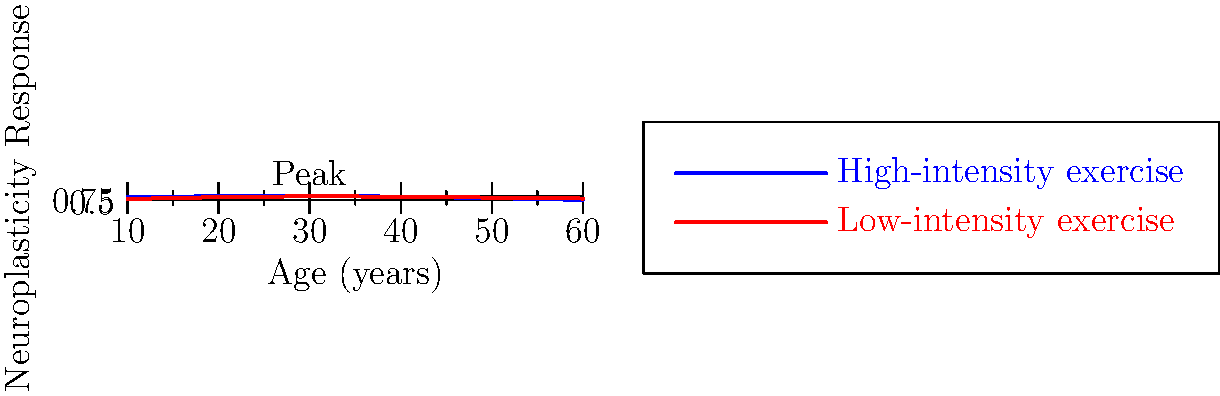Based on the graph showing neuroplasticity responses to exercise across different age groups, at which age does the difference in neuroplasticity response between high-intensity and low-intensity exercise appear to be the greatest? To determine the age at which the difference in neuroplasticity response between high-intensity and low-intensity exercise is greatest, we need to follow these steps:

1. Examine the two curves: blue for high-intensity exercise and red for low-intensity exercise.
2. Look for the point where the vertical distance between the two curves is largest.
3. Identify the age (x-axis value) corresponding to this point.

Analyzing the graph:
- At age 10, there's a small difference between the curves.
- The difference increases at age 20.
- At age 30, the curves are close together, with high-intensity slightly higher.
- At age 40, the curves almost overlap.
- At age 50, we see a notable separation between the curves.
- At age 60, the separation is even more pronounced, with high-intensity exercise showing a much higher neuroplasticity response compared to low-intensity exercise.

The vertical distance between the two curves appears to be largest at age 60, indicating that this is the age where the difference in neuroplasticity response between high-intensity and low-intensity exercise is greatest.
Answer: 60 years 